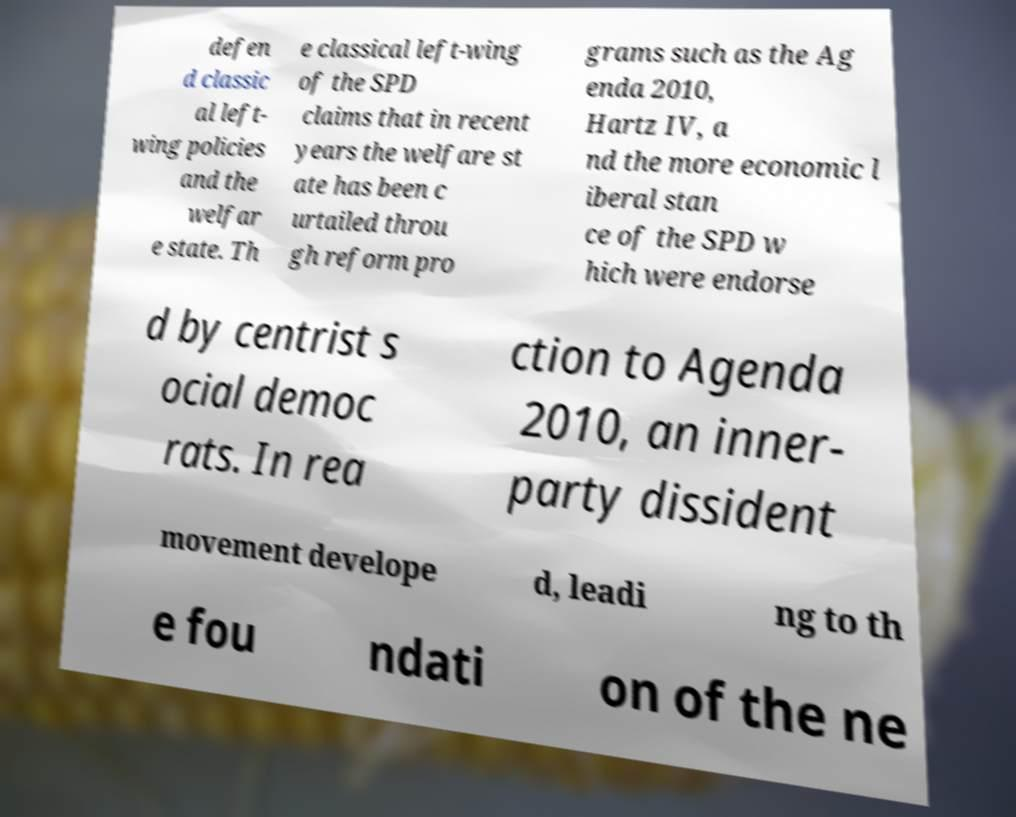There's text embedded in this image that I need extracted. Can you transcribe it verbatim? defen d classic al left- wing policies and the welfar e state. Th e classical left-wing of the SPD claims that in recent years the welfare st ate has been c urtailed throu gh reform pro grams such as the Ag enda 2010, Hartz IV, a nd the more economic l iberal stan ce of the SPD w hich were endorse d by centrist s ocial democ rats. In rea ction to Agenda 2010, an inner- party dissident movement develope d, leadi ng to th e fou ndati on of the ne 